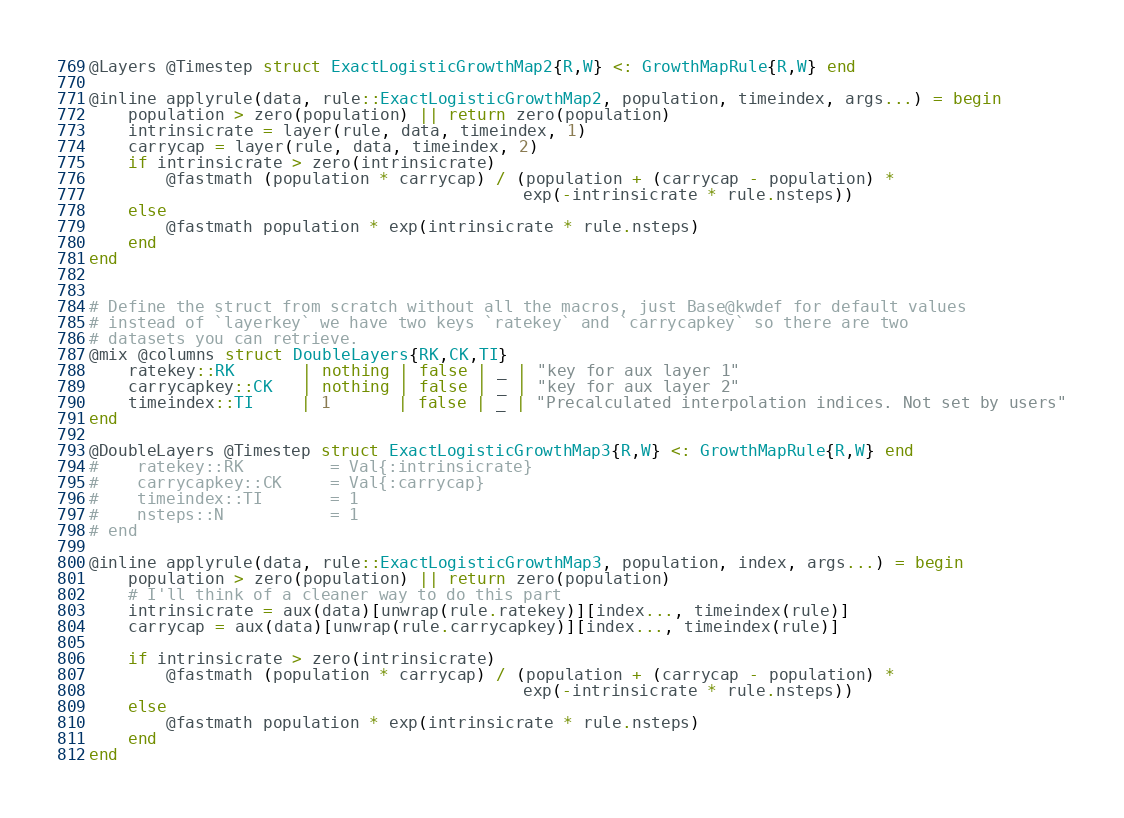<code> <loc_0><loc_0><loc_500><loc_500><_Julia_>
@Layers @Timestep struct ExactLogisticGrowthMap2{R,W} <: GrowthMapRule{R,W} end

@inline applyrule(data, rule::ExactLogisticGrowthMap2, population, timeindex, args...) = begin
    population > zero(population) || return zero(population)
    intrinsicrate = layer(rule, data, timeindex, 1)
    carrycap = layer(rule, data, timeindex, 2)
    if intrinsicrate > zero(intrinsicrate)
        @fastmath (population * carrycap) / (population + (carrycap - population) *
                                             exp(-intrinsicrate * rule.nsteps))
    else
        @fastmath population * exp(intrinsicrate * rule.nsteps)
    end
end


# Define the struct from scratch without all the macros, just Base@kwdef for default values
# instead of `layerkey` we have two keys `ratekey` and `carrycapkey` so there are two
# datasets you can retrieve. 
@mix @columns struct DoubleLayers{RK,CK,TI}
    ratekey::RK       | nothing | false | _ | "key for aux layer 1"
    carrycapkey::CK   | nothing | false | _ | "key for aux layer 2"
    timeindex::TI     | 1       | false | _ | "Precalculated interpolation indices. Not set by users"
end

@DoubleLayers @Timestep struct ExactLogisticGrowthMap3{R,W} <: GrowthMapRule{R,W} end
#    ratekey::RK         = Val{:intrinsicrate}
#    carrycapkey::CK     = Val{:carrycap}
#    timeindex::TI       = 1
#    nsteps::N           = 1
# end

@inline applyrule(data, rule::ExactLogisticGrowthMap3, population, index, args...) = begin
    population > zero(population) || return zero(population)
    # I'll think of a cleaner way to do this part
    intrinsicrate = aux(data)[unwrap(rule.ratekey)][index..., timeindex(rule)]
    carrycap = aux(data)[unwrap(rule.carrycapkey)][index..., timeindex(rule)]

    if intrinsicrate > zero(intrinsicrate)
        @fastmath (population * carrycap) / (population + (carrycap - population) *
                                             exp(-intrinsicrate * rule.nsteps))
    else
        @fastmath population * exp(intrinsicrate * rule.nsteps)
    end
end</code> 